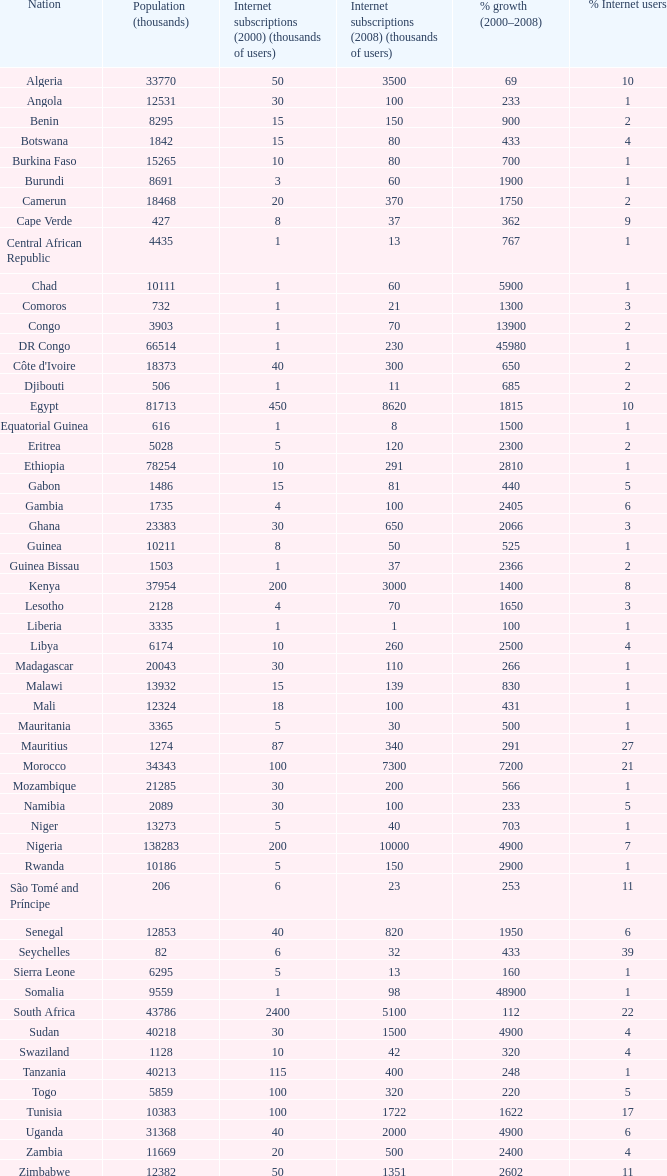Between 2000 and 2008, what was the peak percentage of growth in burundi? 1900.0. Could you help me parse every detail presented in this table? {'header': ['Nation', 'Population (thousands)', 'Internet subscriptions (2000) (thousands of users)', 'Internet subscriptions (2008) (thousands of users)', '% growth (2000–2008)', '% Internet users'], 'rows': [['Algeria', '33770', '50', '3500', '69', '10'], ['Angola', '12531', '30', '100', '233', '1'], ['Benin', '8295', '15', '150', '900', '2'], ['Botswana', '1842', '15', '80', '433', '4'], ['Burkina Faso', '15265', '10', '80', '700', '1'], ['Burundi', '8691', '3', '60', '1900', '1'], ['Camerun', '18468', '20', '370', '1750', '2'], ['Cape Verde', '427', '8', '37', '362', '9'], ['Central African Republic', '4435', '1', '13', '767', '1'], ['Chad', '10111', '1', '60', '5900', '1'], ['Comoros', '732', '1', '21', '1300', '3'], ['Congo', '3903', '1', '70', '13900', '2'], ['DR Congo', '66514', '1', '230', '45980', '1'], ["Côte d'Ivoire", '18373', '40', '300', '650', '2'], ['Djibouti', '506', '1', '11', '685', '2'], ['Egypt', '81713', '450', '8620', '1815', '10'], ['Equatorial Guinea', '616', '1', '8', '1500', '1'], ['Eritrea', '5028', '5', '120', '2300', '2'], ['Ethiopia', '78254', '10', '291', '2810', '1'], ['Gabon', '1486', '15', '81', '440', '5'], ['Gambia', '1735', '4', '100', '2405', '6'], ['Ghana', '23383', '30', '650', '2066', '3'], ['Guinea', '10211', '8', '50', '525', '1'], ['Guinea Bissau', '1503', '1', '37', '2366', '2'], ['Kenya', '37954', '200', '3000', '1400', '8'], ['Lesotho', '2128', '4', '70', '1650', '3'], ['Liberia', '3335', '1', '1', '100', '1'], ['Libya', '6174', '10', '260', '2500', '4'], ['Madagascar', '20043', '30', '110', '266', '1'], ['Malawi', '13932', '15', '139', '830', '1'], ['Mali', '12324', '18', '100', '431', '1'], ['Mauritania', '3365', '5', '30', '500', '1'], ['Mauritius', '1274', '87', '340', '291', '27'], ['Morocco', '34343', '100', '7300', '7200', '21'], ['Mozambique', '21285', '30', '200', '566', '1'], ['Namibia', '2089', '30', '100', '233', '5'], ['Niger', '13273', '5', '40', '703', '1'], ['Nigeria', '138283', '200', '10000', '4900', '7'], ['Rwanda', '10186', '5', '150', '2900', '1'], ['São Tomé and Príncipe', '206', '6', '23', '253', '11'], ['Senegal', '12853', '40', '820', '1950', '6'], ['Seychelles', '82', '6', '32', '433', '39'], ['Sierra Leone', '6295', '5', '13', '160', '1'], ['Somalia', '9559', '1', '98', '48900', '1'], ['South Africa', '43786', '2400', '5100', '112', '22'], ['Sudan', '40218', '30', '1500', '4900', '4'], ['Swaziland', '1128', '10', '42', '320', '4'], ['Tanzania', '40213', '115', '400', '248', '1'], ['Togo', '5859', '100', '320', '220', '5'], ['Tunisia', '10383', '100', '1722', '1622', '17'], ['Uganda', '31368', '40', '2000', '4900', '6'], ['Zambia', '11669', '20', '500', '2400', '4'], ['Zimbabwe', '12382', '50', '1351', '2602', '11']]} 